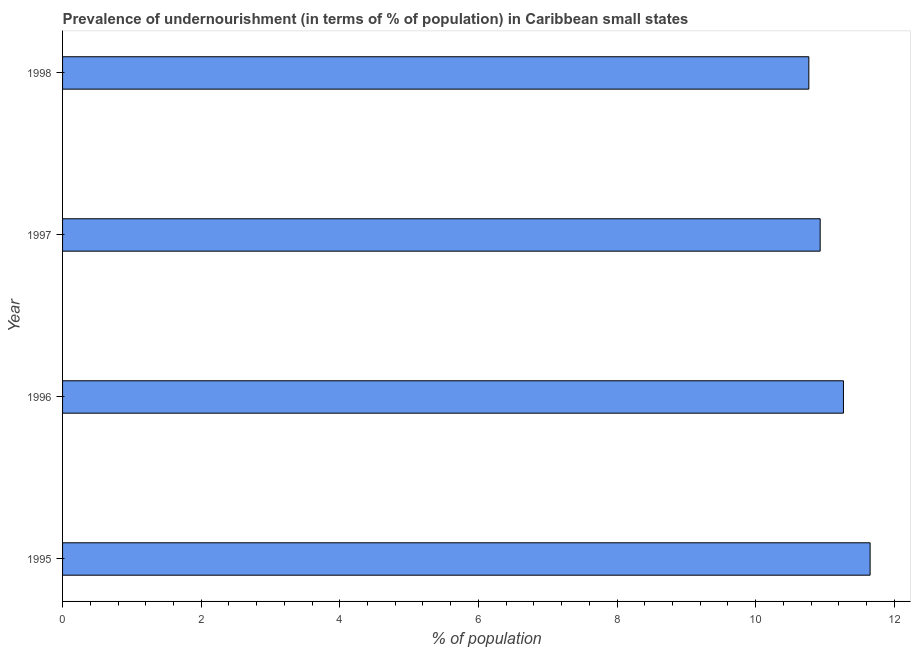Does the graph contain grids?
Your response must be concise. No. What is the title of the graph?
Your answer should be very brief. Prevalence of undernourishment (in terms of % of population) in Caribbean small states. What is the label or title of the X-axis?
Your answer should be compact. % of population. What is the label or title of the Y-axis?
Give a very brief answer. Year. What is the percentage of undernourished population in 1995?
Make the answer very short. 11.65. Across all years, what is the maximum percentage of undernourished population?
Make the answer very short. 11.65. Across all years, what is the minimum percentage of undernourished population?
Your response must be concise. 10.77. In which year was the percentage of undernourished population maximum?
Offer a terse response. 1995. In which year was the percentage of undernourished population minimum?
Ensure brevity in your answer.  1998. What is the sum of the percentage of undernourished population?
Your response must be concise. 44.61. What is the difference between the percentage of undernourished population in 1995 and 1996?
Provide a succinct answer. 0.39. What is the average percentage of undernourished population per year?
Provide a succinct answer. 11.15. What is the median percentage of undernourished population?
Your response must be concise. 11.1. In how many years, is the percentage of undernourished population greater than 9.6 %?
Make the answer very short. 4. What is the ratio of the percentage of undernourished population in 1995 to that in 1997?
Provide a succinct answer. 1.07. Is the percentage of undernourished population in 1996 less than that in 1997?
Your response must be concise. No. What is the difference between the highest and the second highest percentage of undernourished population?
Make the answer very short. 0.39. Is the sum of the percentage of undernourished population in 1997 and 1998 greater than the maximum percentage of undernourished population across all years?
Provide a succinct answer. Yes. What is the % of population of 1995?
Keep it short and to the point. 11.65. What is the % of population of 1996?
Ensure brevity in your answer.  11.27. What is the % of population in 1997?
Your response must be concise. 10.93. What is the % of population in 1998?
Provide a short and direct response. 10.77. What is the difference between the % of population in 1995 and 1996?
Give a very brief answer. 0.38. What is the difference between the % of population in 1995 and 1997?
Offer a terse response. 0.72. What is the difference between the % of population in 1995 and 1998?
Your answer should be compact. 0.88. What is the difference between the % of population in 1996 and 1997?
Give a very brief answer. 0.34. What is the difference between the % of population in 1996 and 1998?
Give a very brief answer. 0.5. What is the difference between the % of population in 1997 and 1998?
Ensure brevity in your answer.  0.16. What is the ratio of the % of population in 1995 to that in 1996?
Offer a terse response. 1.03. What is the ratio of the % of population in 1995 to that in 1997?
Offer a terse response. 1.07. What is the ratio of the % of population in 1995 to that in 1998?
Your response must be concise. 1.08. What is the ratio of the % of population in 1996 to that in 1997?
Make the answer very short. 1.03. What is the ratio of the % of population in 1996 to that in 1998?
Offer a very short reply. 1.05. 